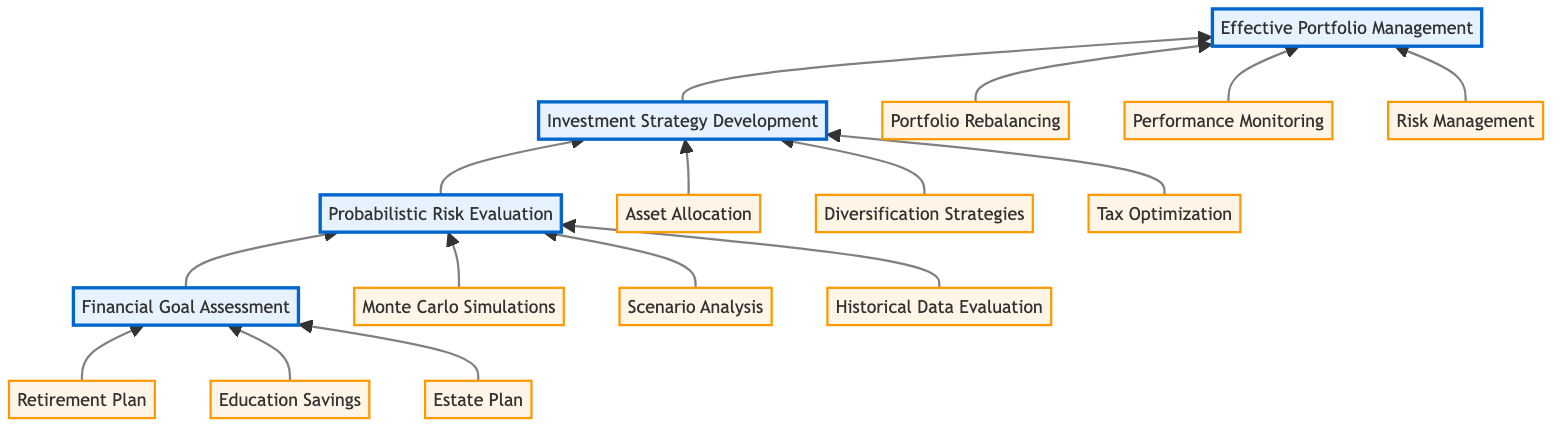What is the top stage of the financial planning process? The diagram indicates that the top stage is labeled "Effective Portfolio Management."
Answer: Effective Portfolio Management How many stages are there in the financial planning diagram? Counting the stages from bottom to top, there are four distinct stages: Financial Goal Assessment, Probabilistic Risk Evaluation, Investment Strategy Development, and Effective Portfolio Management.
Answer: Four What is the relationship between "Investment Strategy Development" and "Effective Portfolio Management"? "Investment Strategy Development" is directly below "Effective Portfolio Management," indicating that it is a prerequisite stage before managing the investment portfolio effectively.
Answer: Prerequisite Which entities are associated with "Probabilistic Risk Evaluation"? The entities connected to "Probabilistic Risk Evaluation" are Monte Carlo Simulations, Scenario Analysis, and Historical Data Evaluation.
Answer: Monte Carlo Simulations, Scenario Analysis, Historical Data Evaluation Which stage comes after "Probabilistic Risk Evaluation"? Following "Probabilistic Risk Evaluation," the next stage is "Investment Strategy Development."
Answer: Investment Strategy Development What is the lowest stage in the financial planning flow? The diagram starts with "Financial Goal Assessment" at the bottom, making it the lowest stage in the flow.
Answer: Financial Goal Assessment Which investment strategies are included in the "Investment Strategy Development" stage? The strategies associated with "Investment Strategy Development" are Asset Allocation, Diversification Strategies, and Tax Optimization.
Answer: Asset Allocation, Diversification Strategies, Tax Optimization What does the flow of the chart indicate about the progression between stages? The upward arrows indicate a progression, signifying that each stage builds upon the previous one, culminating in effective portfolio management.
Answer: Progression What performs the role of risk management in the final stage? The diagram shows that "Risk Management" is one of the entities associated with "Effective Portfolio Management", thereby indicating its role in the final stage.
Answer: Risk Management 